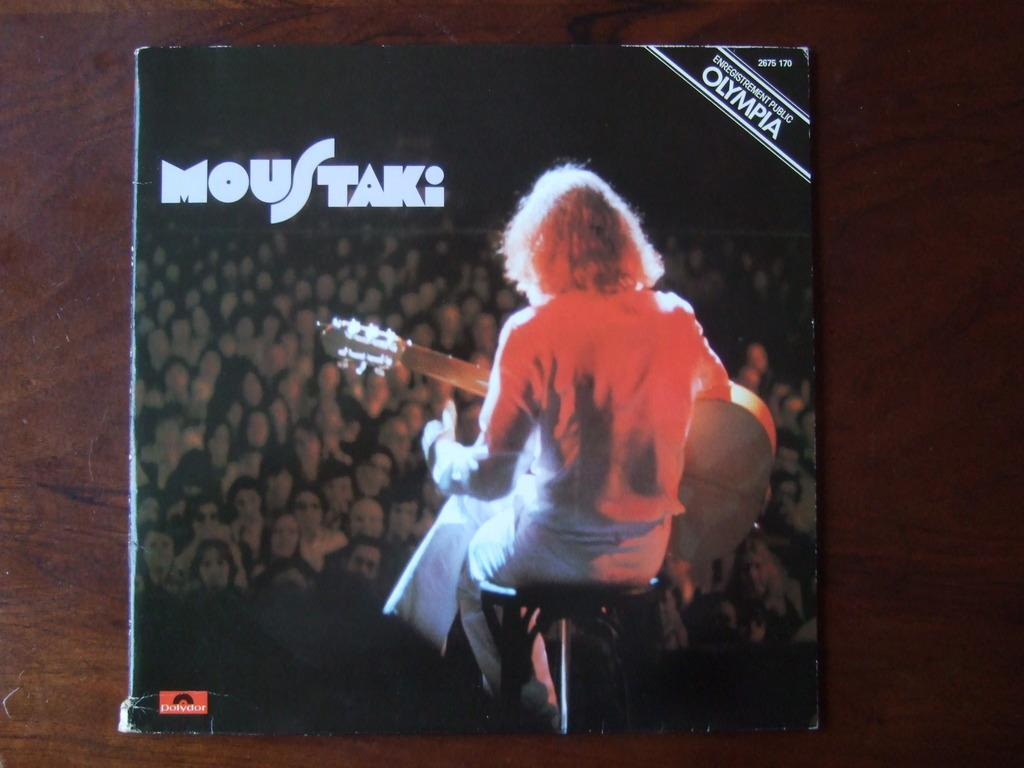Provide a one-sentence caption for the provided image. Olympia album cover for MousTaki she is sitting with a guitar for the audience. 